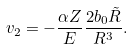Convert formula to latex. <formula><loc_0><loc_0><loc_500><loc_500>v _ { 2 } = - \frac { \alpha Z } { E } \frac { 2 b _ { 0 } \tilde { R } } { R ^ { 3 } } .</formula> 